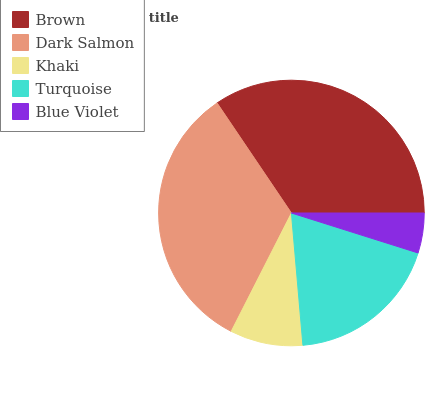Is Blue Violet the minimum?
Answer yes or no. Yes. Is Brown the maximum?
Answer yes or no. Yes. Is Dark Salmon the minimum?
Answer yes or no. No. Is Dark Salmon the maximum?
Answer yes or no. No. Is Brown greater than Dark Salmon?
Answer yes or no. Yes. Is Dark Salmon less than Brown?
Answer yes or no. Yes. Is Dark Salmon greater than Brown?
Answer yes or no. No. Is Brown less than Dark Salmon?
Answer yes or no. No. Is Turquoise the high median?
Answer yes or no. Yes. Is Turquoise the low median?
Answer yes or no. Yes. Is Blue Violet the high median?
Answer yes or no. No. Is Dark Salmon the low median?
Answer yes or no. No. 